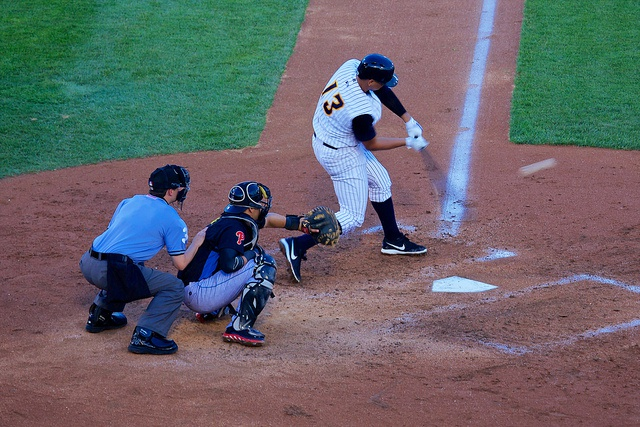Describe the objects in this image and their specific colors. I can see people in darkgreen, lightblue, black, and gray tones, people in darkgreen, black, navy, blue, and lightblue tones, people in darkgreen, black, navy, and gray tones, baseball glove in darkgreen, navy, gray, black, and darkblue tones, and baseball bat in darkgreen, purple, gray, darkgray, and lightblue tones in this image. 